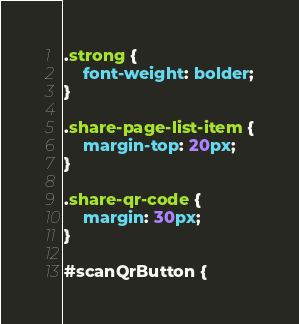Convert code to text. <code><loc_0><loc_0><loc_500><loc_500><_CSS_>.strong {
    font-weight: bolder;
}

.share-page-list-item {
    margin-top: 20px;
}

.share-qr-code {
    margin: 30px;
}

#scanQrButton {</code> 